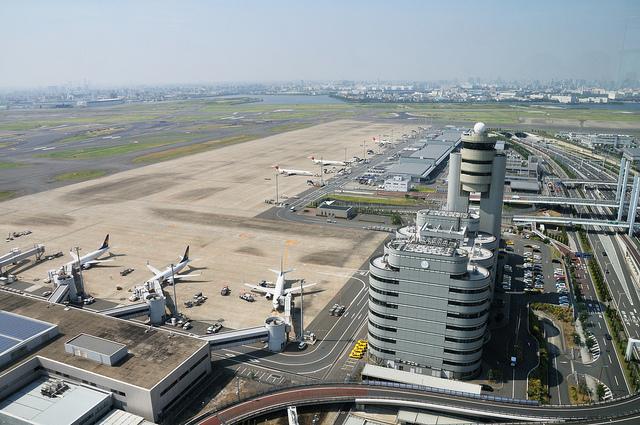Is this a school?
Quick response, please. No. Where is this location at?
Answer briefly. Airport. Are these planes commuter planes or private jets?
Be succinct. Commuter. Is this plane on the runway?
Quick response, please. No. 